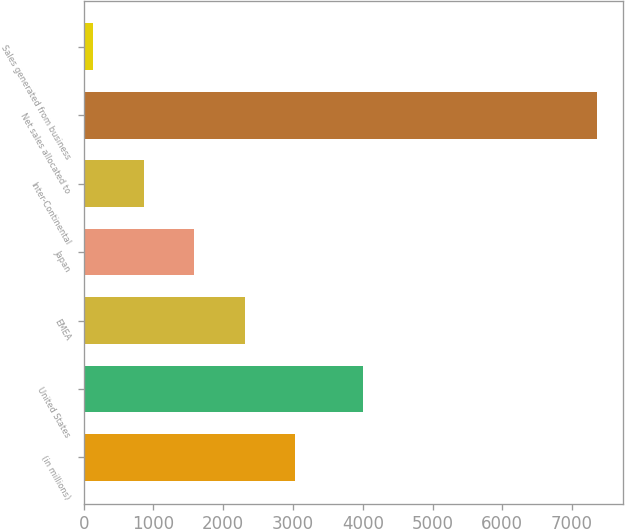Convert chart to OTSL. <chart><loc_0><loc_0><loc_500><loc_500><bar_chart><fcel>(in millions)<fcel>United States<fcel>EMEA<fcel>Japan<fcel>Inter-Continental<fcel>Net sales allocated to<fcel>Sales generated from business<nl><fcel>3027.6<fcel>4010<fcel>2305.7<fcel>1583.8<fcel>861.9<fcel>7359<fcel>140<nl></chart> 